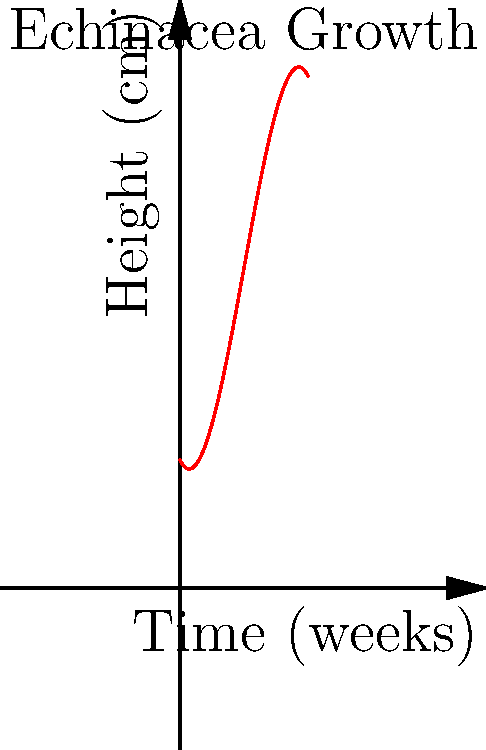The graph above represents the growth of Echinacea, a medicinal herb, over time. The polynomial function modeling this growth is $f(x) = -0.1x^3 + 1.5x^2 - 2x + 10$, where $x$ is the time in weeks and $f(x)$ is the height in centimeters. At what point in time does the Echinacea plant reach its maximum height, and what is that height? To find the maximum height and when it occurs, we need to follow these steps:

1) First, we need to find the derivative of the function:
   $f'(x) = -0.3x^2 + 3x - 2$

2) Set the derivative equal to zero to find critical points:
   $-0.3x^2 + 3x - 2 = 0$

3) Solve this quadratic equation:
   $x = \frac{-3 \pm \sqrt{3^2 - 4(-0.3)(-2)}}{2(-0.3)}$
   $x = \frac{-3 \pm \sqrt{9 - 2.4}}{-0.6}$
   $x = \frac{-3 \pm \sqrt{6.6}}{-0.6}$
   $x \approx 6.83$ or $x \approx 1.17$

4) The second derivative is $f''(x) = -0.6x + 3$. At $x = 6.83$, $f''(6.83) < 0$, indicating a maximum.

5) To find the maximum height, plug $x = 6.83$ into the original function:
   $f(6.83) = -0.1(6.83)^3 + 1.5(6.83)^2 - 2(6.83) + 10 \approx 15.4$ cm

Therefore, the Echinacea plant reaches its maximum height of approximately 15.4 cm after about 6.83 weeks.
Answer: 6.83 weeks; 15.4 cm 